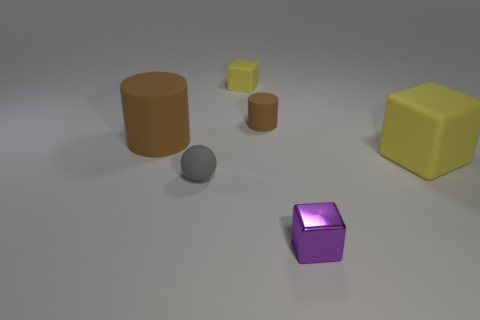Add 2 small green metal things. How many objects exist? 8 Subtract all spheres. How many objects are left? 5 Subtract all tiny blocks. How many blocks are left? 1 Subtract all yellow blocks. How many blocks are left? 1 Subtract all gray balls. How many purple blocks are left? 1 Subtract all large rubber cubes. Subtract all small purple metallic cubes. How many objects are left? 4 Add 6 large matte cubes. How many large matte cubes are left? 7 Add 4 spheres. How many spheres exist? 5 Subtract 0 red spheres. How many objects are left? 6 Subtract 1 balls. How many balls are left? 0 